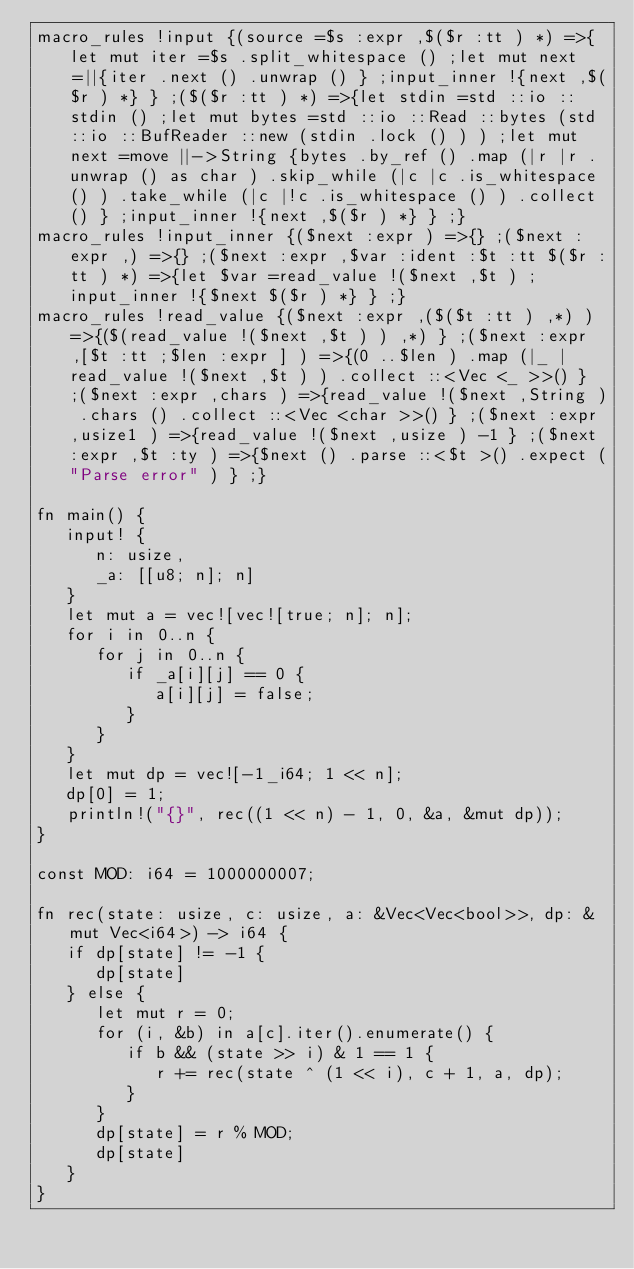Convert code to text. <code><loc_0><loc_0><loc_500><loc_500><_Rust_>macro_rules !input {(source =$s :expr ,$($r :tt ) *) =>{let mut iter =$s .split_whitespace () ;let mut next =||{iter .next () .unwrap () } ;input_inner !{next ,$($r ) *} } ;($($r :tt ) *) =>{let stdin =std ::io ::stdin () ;let mut bytes =std ::io ::Read ::bytes (std ::io ::BufReader ::new (stdin .lock () ) ) ;let mut next =move ||->String {bytes .by_ref () .map (|r |r .unwrap () as char ) .skip_while (|c |c .is_whitespace () ) .take_while (|c |!c .is_whitespace () ) .collect () } ;input_inner !{next ,$($r ) *} } ;}
macro_rules !input_inner {($next :expr ) =>{} ;($next :expr ,) =>{} ;($next :expr ,$var :ident :$t :tt $($r :tt ) *) =>{let $var =read_value !($next ,$t ) ;input_inner !{$next $($r ) *} } ;}
macro_rules !read_value {($next :expr ,($($t :tt ) ,*) ) =>{($(read_value !($next ,$t ) ) ,*) } ;($next :expr ,[$t :tt ;$len :expr ] ) =>{(0 ..$len ) .map (|_ |read_value !($next ,$t ) ) .collect ::<Vec <_ >>() } ;($next :expr ,chars ) =>{read_value !($next ,String ) .chars () .collect ::<Vec <char >>() } ;($next :expr ,usize1 ) =>{read_value !($next ,usize ) -1 } ;($next :expr ,$t :ty ) =>{$next () .parse ::<$t >() .expect ("Parse error" ) } ;}

fn main() {
   input! {
      n: usize,
      _a: [[u8; n]; n]
   }
   let mut a = vec![vec![true; n]; n];
   for i in 0..n {
      for j in 0..n {
         if _a[i][j] == 0 {
            a[i][j] = false;
         }
      }
   }
   let mut dp = vec![-1_i64; 1 << n];
   dp[0] = 1;
   println!("{}", rec((1 << n) - 1, 0, &a, &mut dp));
}

const MOD: i64 = 1000000007;

fn rec(state: usize, c: usize, a: &Vec<Vec<bool>>, dp: &mut Vec<i64>) -> i64 {
   if dp[state] != -1 {
      dp[state]
   } else {
      let mut r = 0;
      for (i, &b) in a[c].iter().enumerate() {
         if b && (state >> i) & 1 == 1 {
            r += rec(state ^ (1 << i), c + 1, a, dp);
         }
      }
      dp[state] = r % MOD;
      dp[state]
   }
}
</code> 